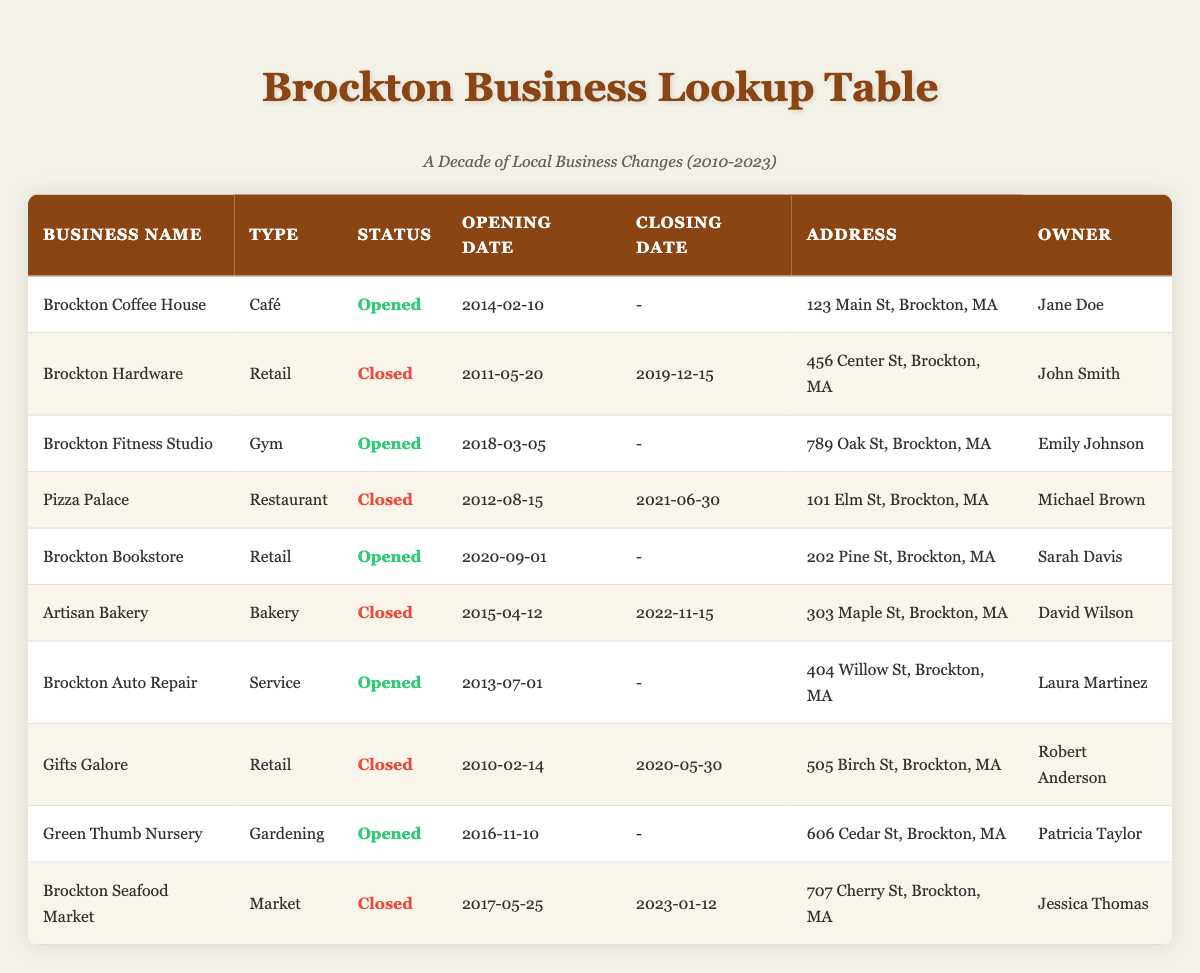What is the status of Brockton Coffee House? The status of Brockton Coffee House is listed in the 'Status' column of the table, which shows it is currently "Opened."
Answer: Opened How many businesses in Brockton have closed? By looking at the status column, I can count the entries marked as "Closed." They are Brockton Hardware, Pizza Palace, Artisan Bakery, Gifts Galore, and Brockton Seafood Market, totaling five businesses.
Answer: 5 What is the opening date of the Brockton Bookstore? The opening date for the Brockton Bookstore is found in the corresponding 'Opening Date' column and is listed as "2020-09-01."
Answer: 2020-09-01 Which business had the most recent closing date? To find the most recent closing date, I compare all entries in the 'Closing Date' column. The entry for Brockton Seafood Market shows the date "2023-01-12," which is the latest among all closing dates provided.
Answer: 2023-01-12 Did any restaurants close in Brockton? I can check the 'Type' column for entries labeled as "Restaurant" and then look at their status. Pizza Palace is marked as "Closed," confirming that a restaurant did close in Brockton.
Answer: Yes How many businesses were opened in 2018 or later? Analyzing the opening dates of the businesses, I find that Brockton Fitness Studio (2018), Brockton Bookstore (2020), and Green Thumb Nursery (2016) were opened in 2018 or later, totaling three.
Answer: 3 Which business owned by John Smith is listed in the table? Searching through the table, I locate John Smith in the 'Owner' column next to Brockton Hardware, and verify the 'Business Name' column indicates that this business is indeed Brockton Hardware.
Answer: Brockton Hardware Is there any bakery that is still in operation? I look through the table for businesses labeled as "Bakery" in the 'Type' column. Artisan Bakery shows a status of "Closed," meaning there are currently no bakeries operating in Brockton.
Answer: No What type of business is located at 404 Willow St, Brockton, MA? By examining the 'Address' column, I find the entry for 404 Willow St, which corresponds to Brockton Auto Repair as indicated in the 'Business Name' column.
Answer: Service 